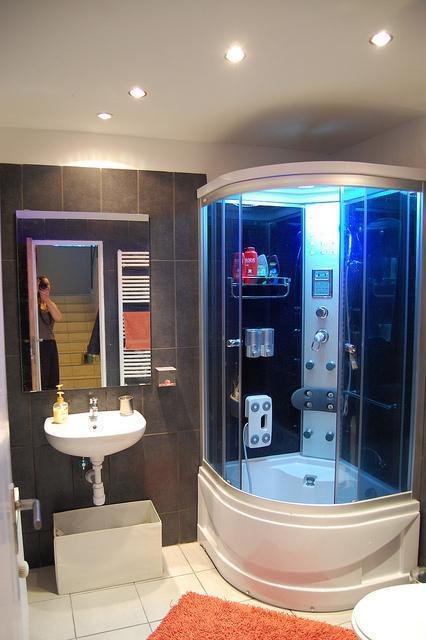How many recessed lights do you see in this photo?
Give a very brief answer. 4. How many bath products are on the top rack in the shower?
Give a very brief answer. 4. How many floor tiles with any part of a cat on them are in the picture?
Give a very brief answer. 0. 